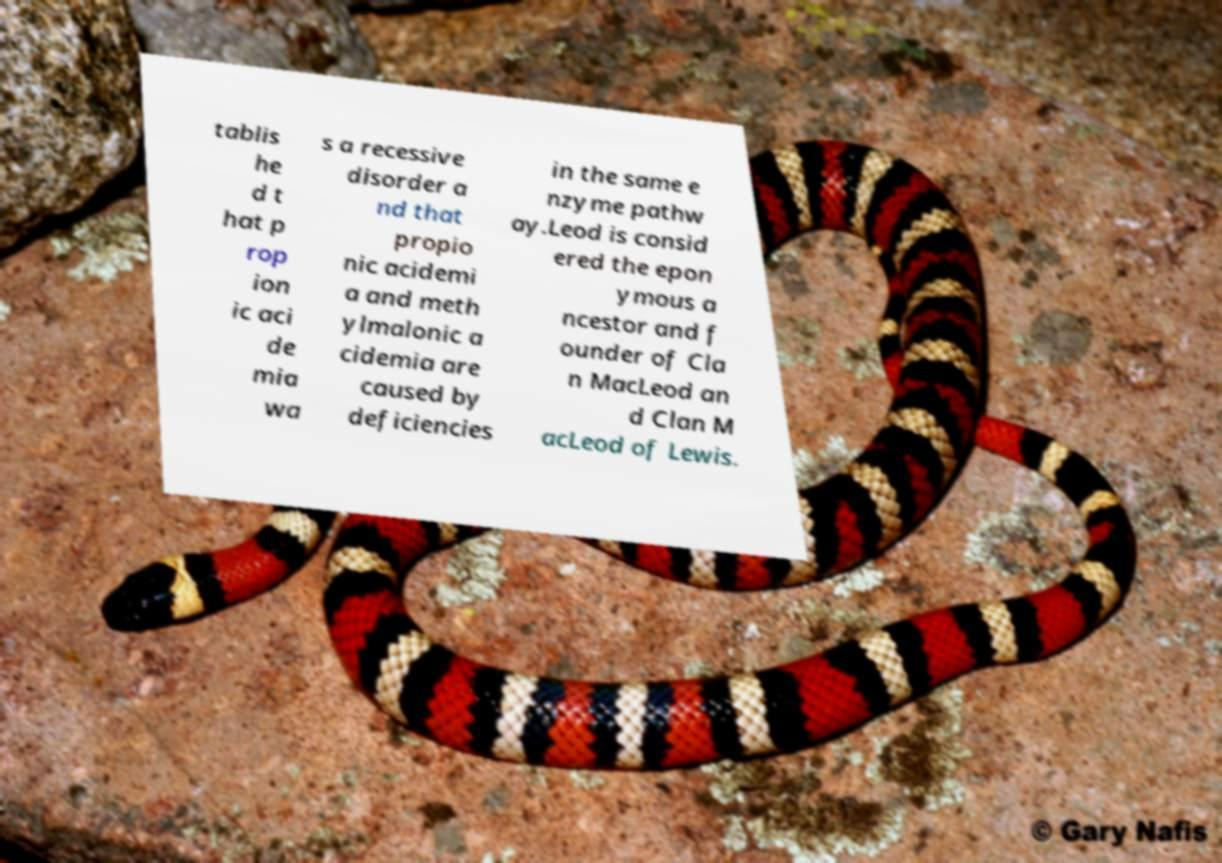Could you extract and type out the text from this image? tablis he d t hat p rop ion ic aci de mia wa s a recessive disorder a nd that propio nic acidemi a and meth ylmalonic a cidemia are caused by deficiencies in the same e nzyme pathw ay.Leod is consid ered the epon ymous a ncestor and f ounder of Cla n MacLeod an d Clan M acLeod of Lewis. 